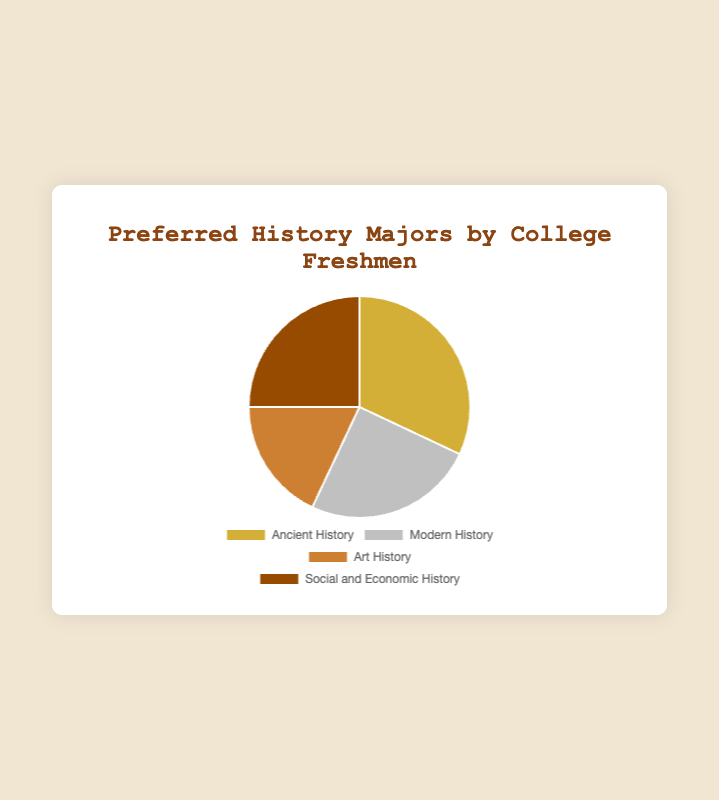What's the most preferred history major among college freshmen? By looking at the pie chart and the corresponding data, the slice representing Ancient History is the largest. Thus, Ancient History is the most preferred history major among college freshmen.
Answer: Ancient History How much more preferred is Ancient History compared to Art History? According to the pie chart, Ancient History has 32%, while Art History has 18%. The difference is calculated as 32% - 18% = 14%.
Answer: 14% Which two history majors have the same preference percentage? From the pie chart, it is seen that Modern History and Social and Economic History both have 25%. So, these two history majors have the same preference percentage.
Answer: Modern History and Social and Economic History What is the total preference percentage for all history majors that have a percentage greater than or equal to 25%? The history majors that have a percentage greater than or equal to 25% are Ancient History (32%), Modern History (25%), and Social and Economic History (25%). Summing these up results in 32% + 25% + 25% = 82%.
Answer: 82% Which history major has the smallest preference percentage, and what is it? By observing the pie chart, Art History has the smallest slice, indicating that it has the smallest preference percentage. From the data, the percentage for Art History is 18%.
Answer: Art History - 18% What is the average preference percentage of all history majors? Summing all the given percentages: 32% (Ancient History) + 25% (Modern History) + 18% (Art History) + 25% (Social and Economic History) = 100%. The average is then 100% / 4 = 25%.
Answer: 25% How does the preference for Modern History compare visually to Social and Economic History? Visually, both Modern History and Social and Economic History occupy the same size slices in the pie chart, indicating that they have the same preference percentage.
Answer: Same size If one more history major was added with a percentage of 20%, what would be the new total percentage of preferred history majors? Initially, the sum of all given percentages is 100%. Adding another history major with 20% would result in a new total of 100% + 20% = 120%.
Answer: 120% 